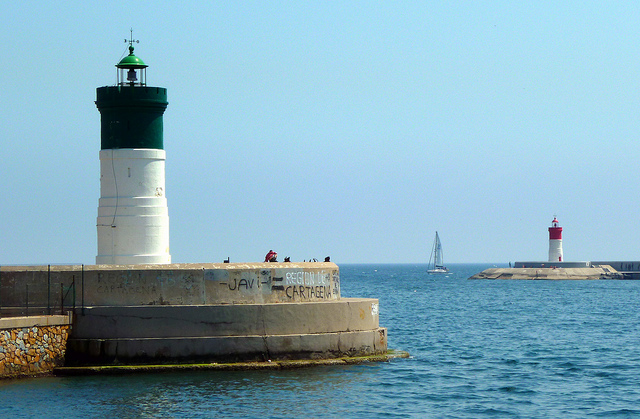How many lighthouses do you see? I see two lighthouses. One prominently positioned in the foreground with a green top, while the second one is farther away, painted red and white. They serve as critical navigational aids for the boats in the area. 